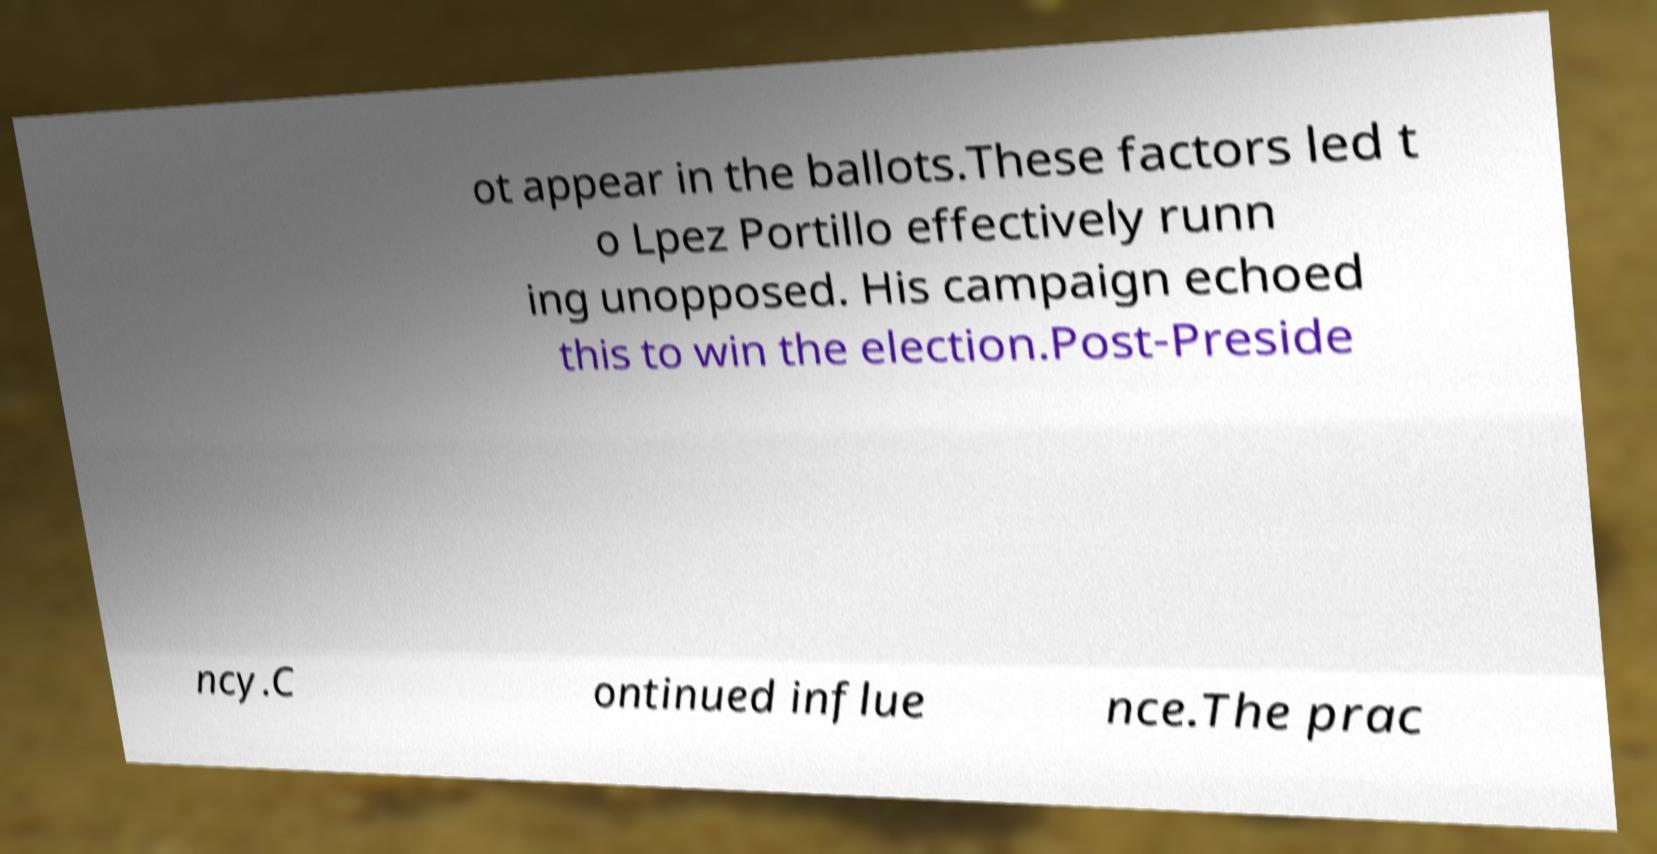There's text embedded in this image that I need extracted. Can you transcribe it verbatim? ot appear in the ballots.These factors led t o Lpez Portillo effectively runn ing unopposed. His campaign echoed this to win the election.Post-Preside ncy.C ontinued influe nce.The prac 